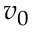Convert formula to latex. <formula><loc_0><loc_0><loc_500><loc_500>v _ { 0 }</formula> 